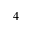<formula> <loc_0><loc_0><loc_500><loc_500>_ { 4 }</formula> 